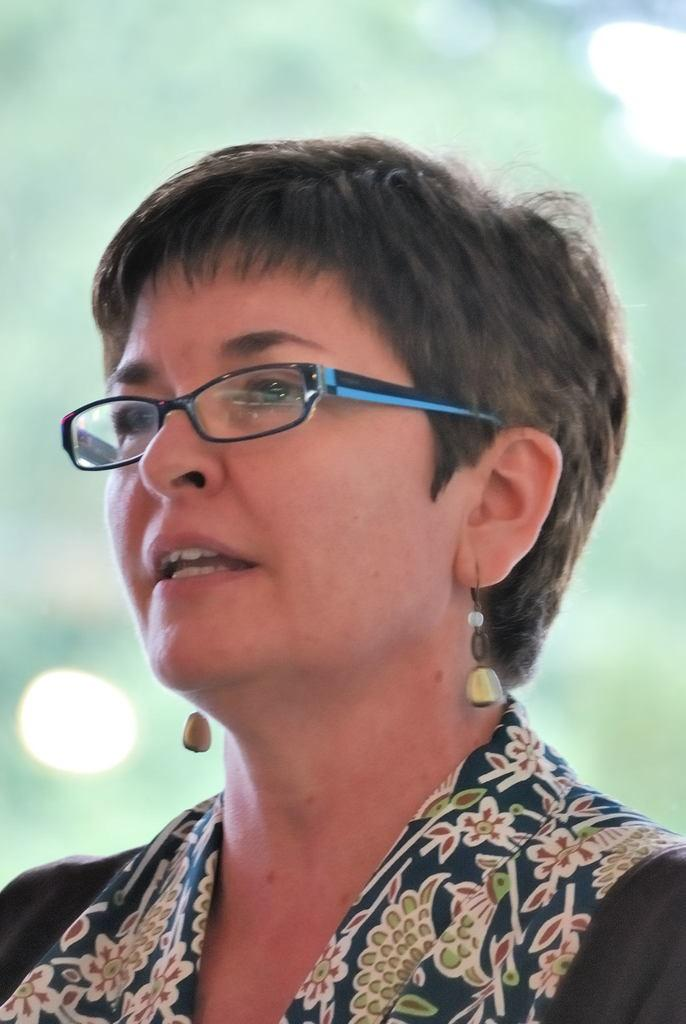Who is the main subject in the image? There is a woman in the image. What is the woman wearing? The woman is wearing a dress, earrings, and spectacles. Can you describe the background of the image? The background of the image is blurred. What type of minister can be seen in the image? There is no minister present in the image; it features a woman wearing a dress, earrings, and spectacles. How many thumbs does the woman have in the image? The image does not show the woman's hands or thumbs, so it cannot be determined from the image. 